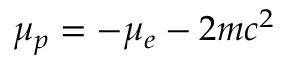Convert formula to latex. <formula><loc_0><loc_0><loc_500><loc_500>\mu _ { p } = - \mu _ { e } - 2 m c ^ { 2 }</formula> 